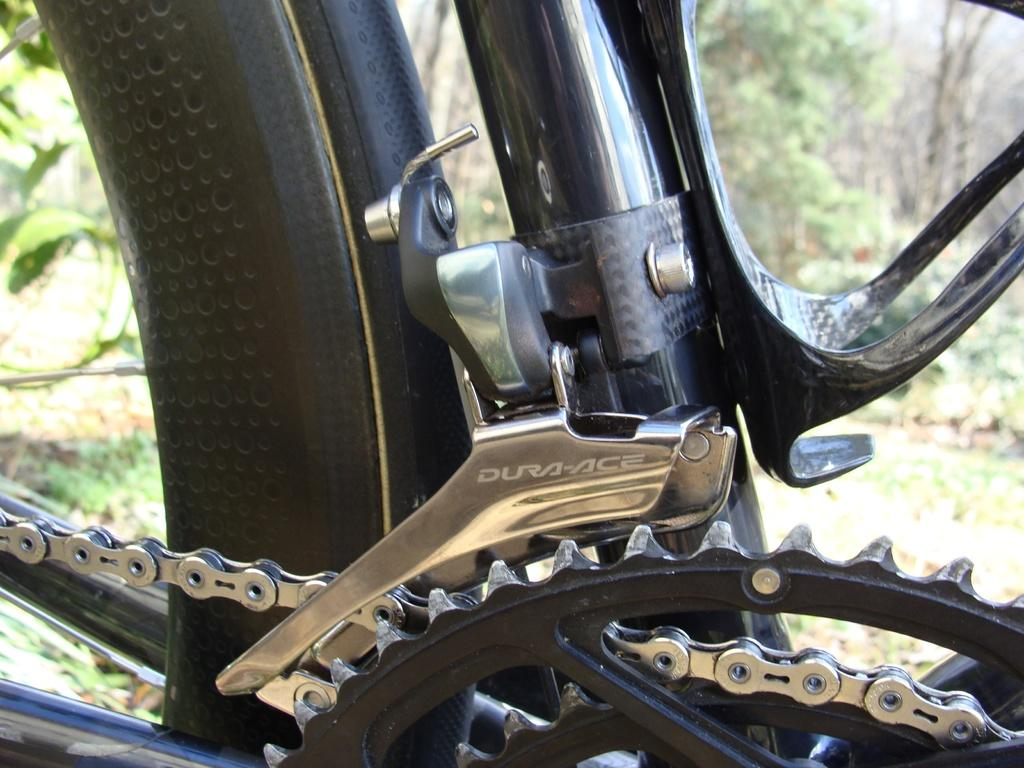What type of object is partially visible in the image? There is a part of a vehicle in the image. What can be seen beneath the vehicle? The ground is visible in the image. How would you describe the background of the image? The background of the image is blurred. What type of furniture can be seen in the image? There is no furniture present in the image. How many points are visible in the image? There are no points visible in the image. 